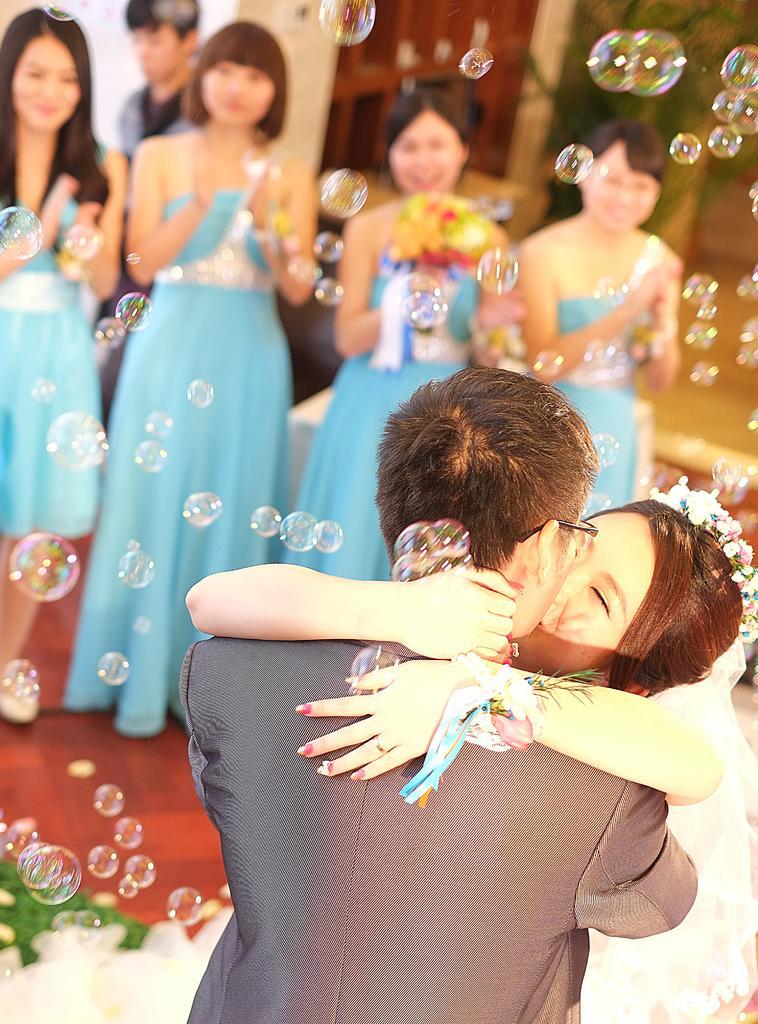Can you describe this image briefly? In this image I can see group of people standing. In front the person is wearing gray color blazer and the person at right is wearing white color dress. Background I can see few bubbles, a plant in green color and the wall is in brown color. 